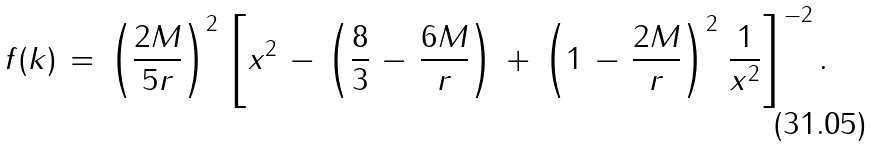<formula> <loc_0><loc_0><loc_500><loc_500>f ( k ) \, = \, \left ( \frac { 2 M } { 5 r } \right ) ^ { 2 } \, \left [ x ^ { 2 } \, - \, \left ( \frac { 8 } { 3 } \, - \, \frac { 6 M } { r } \right ) \, + \, \left ( 1 \, - \, \frac { 2 M } { r } \right ) ^ { 2 } \, \frac { 1 } { x ^ { 2 } } \right ] ^ { \, - 2 } .</formula> 